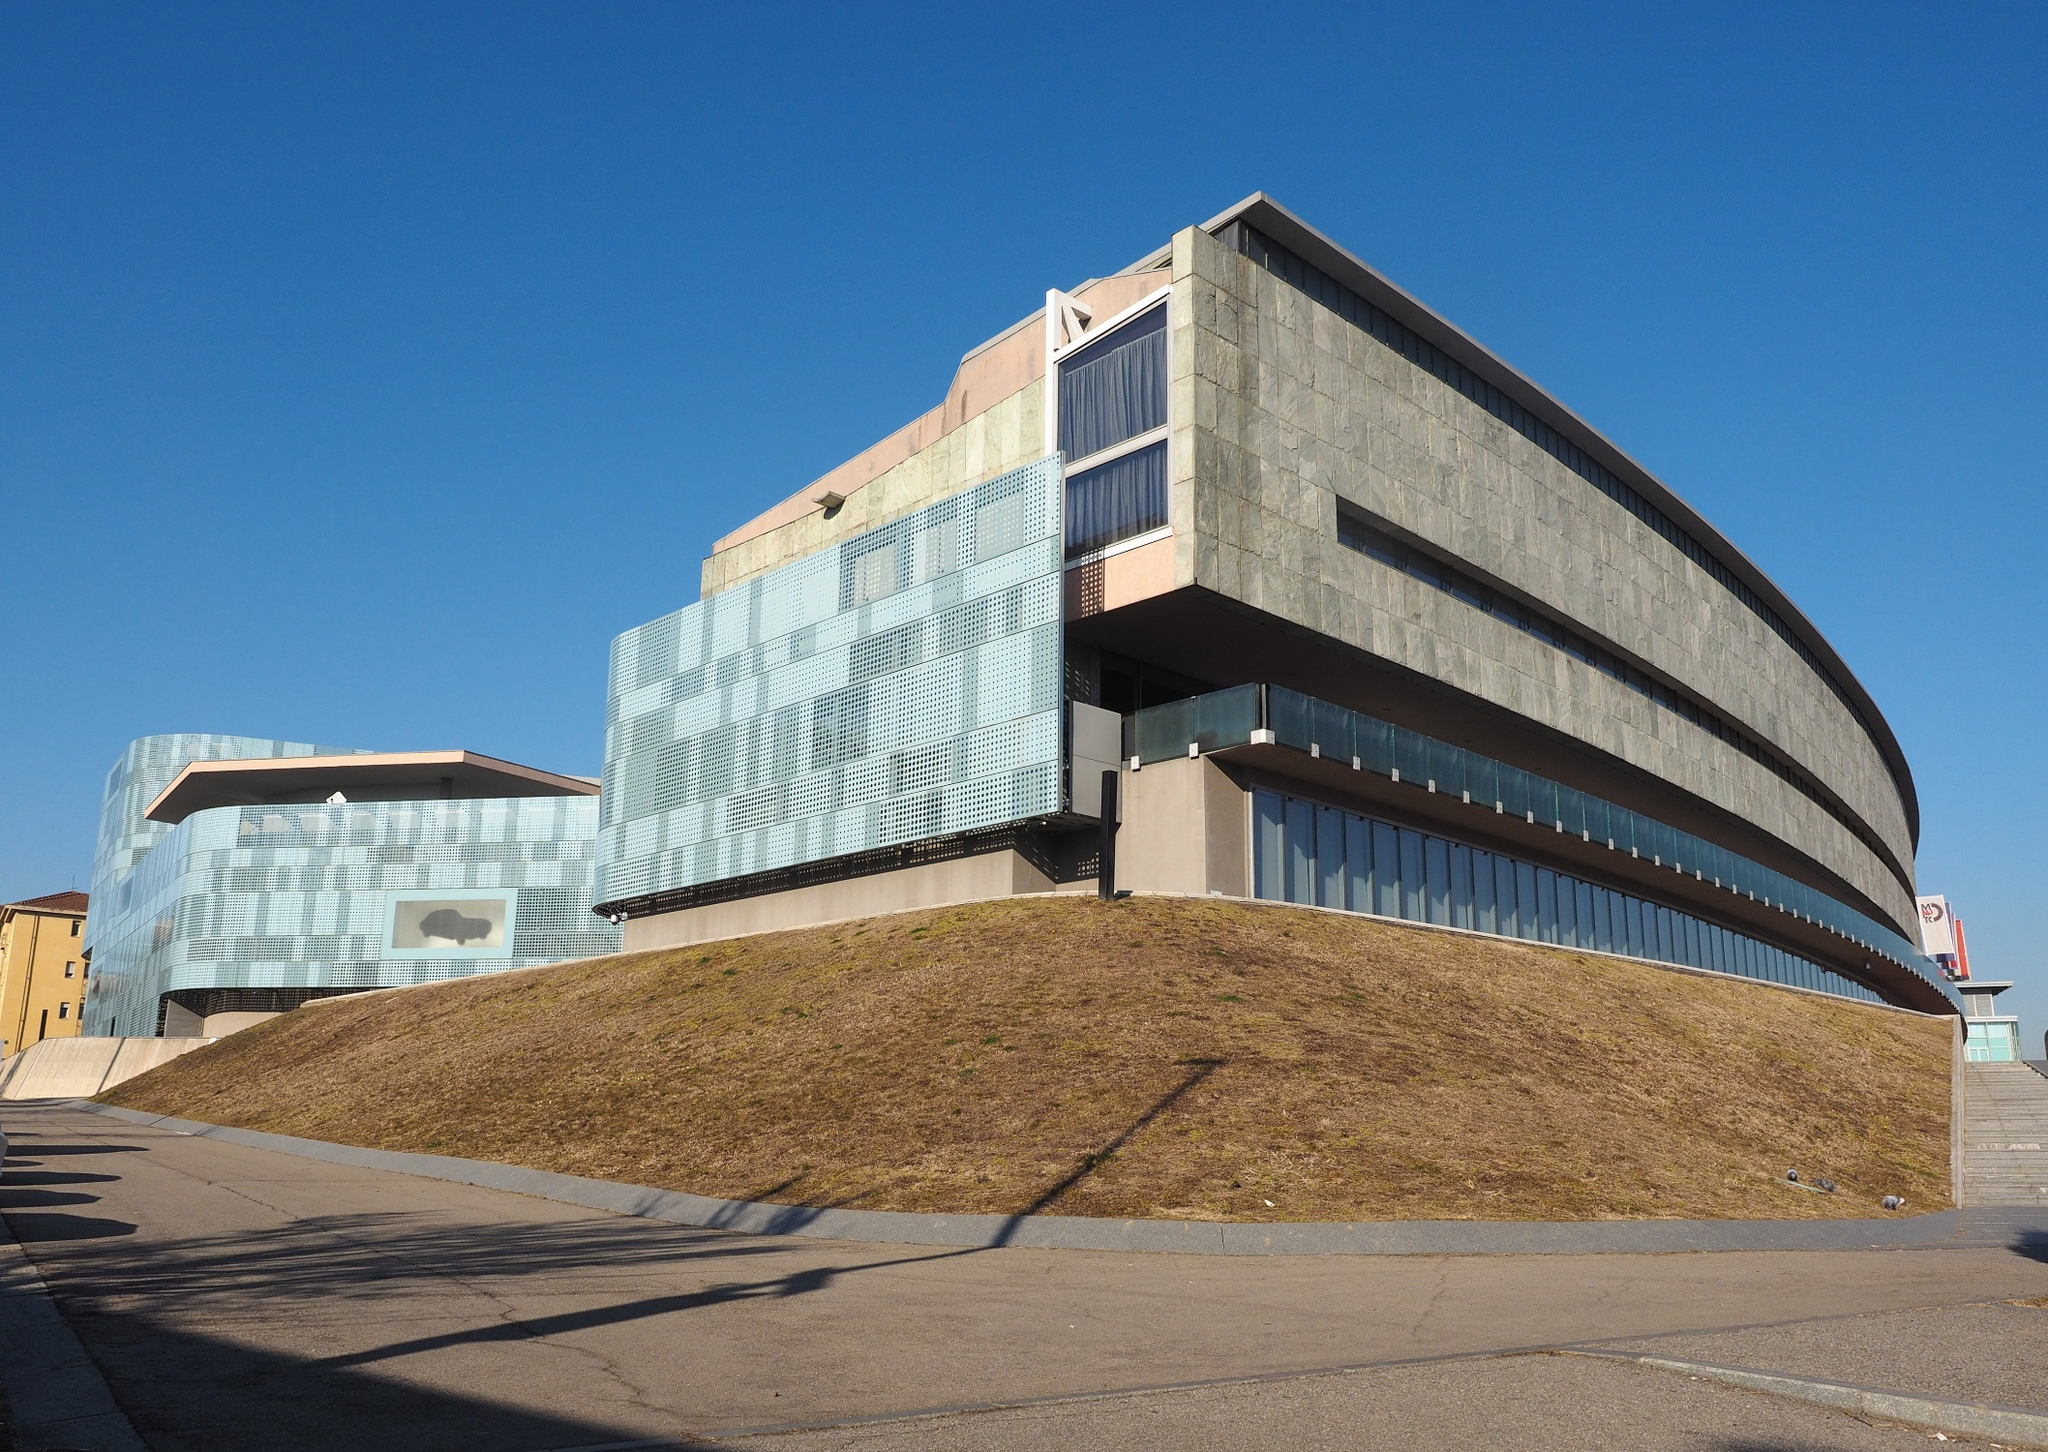How does the architectural design interact with its environment? The building's design demonstrates a thoughtful integration with its environment, utilizing a hilltop position to enhance visibility and dominance in the landscape. The use of reflective glass mirrors the sky and clouds, blending the structure with its backdrop on clear days. Furthermore, the curvilinear forms could be seen as a nod to natural shapes, softening the overall impact of a large man-made object in a possibly natural setting. 